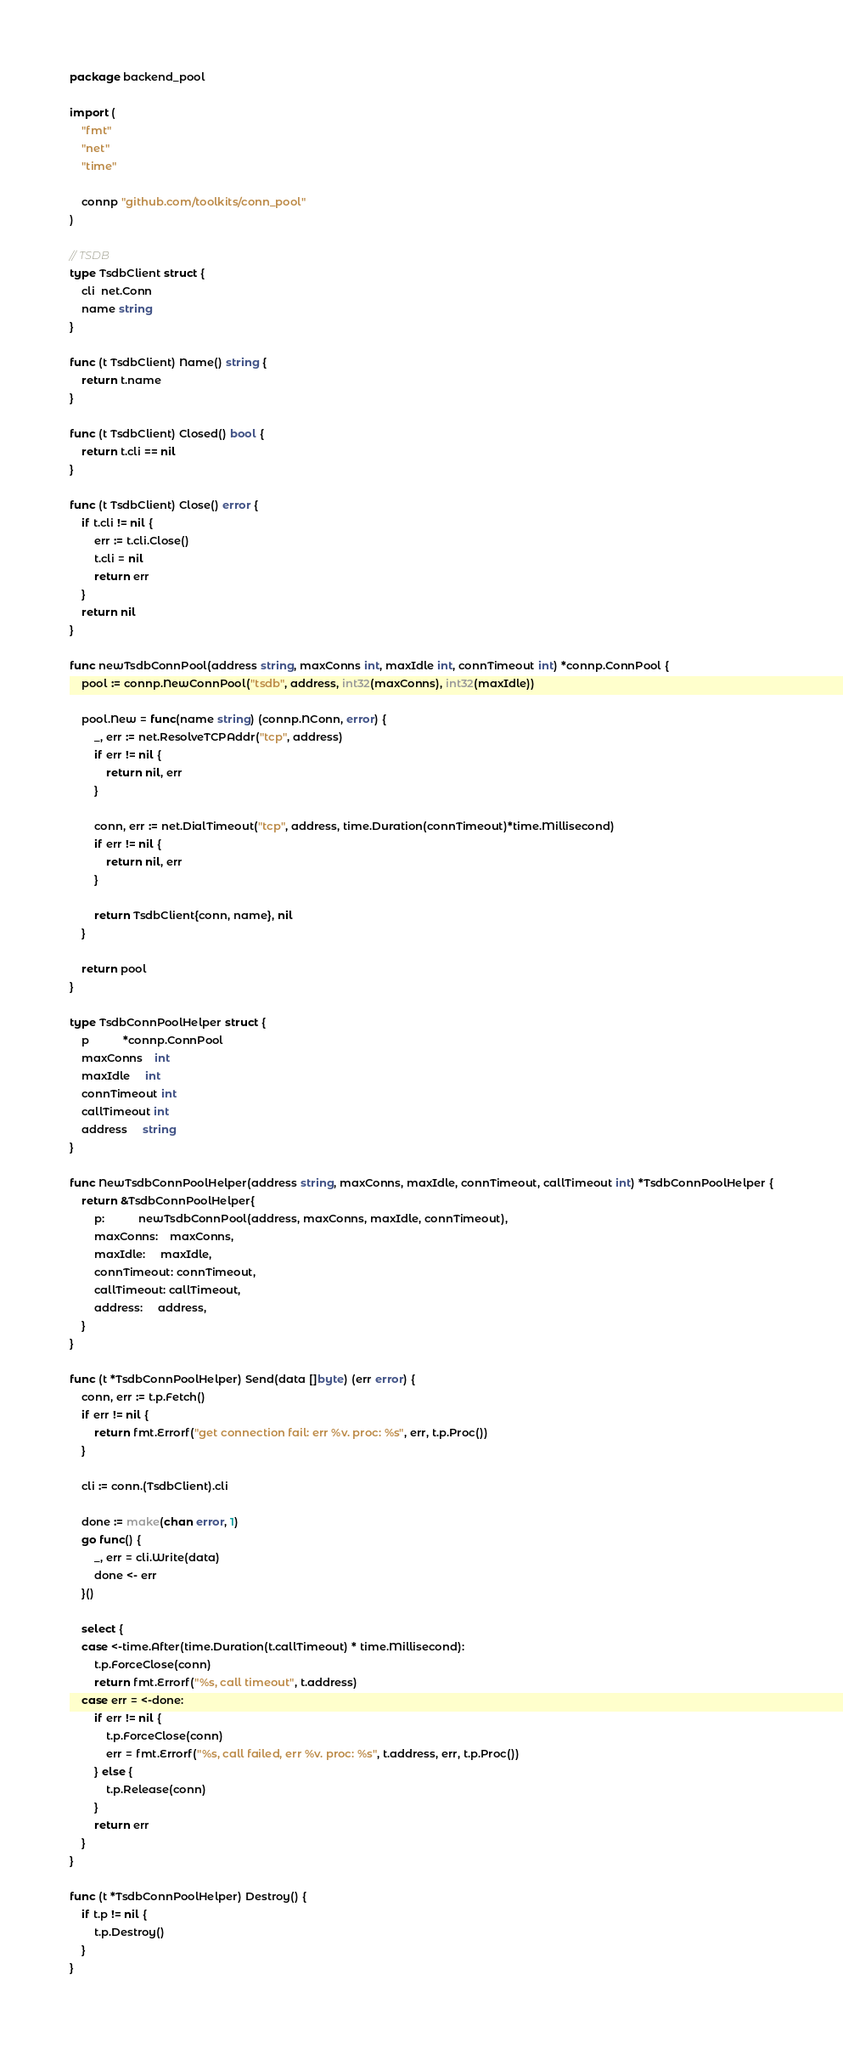<code> <loc_0><loc_0><loc_500><loc_500><_Go_>package backend_pool

import (
	"fmt"
	"net"
	"time"

	connp "github.com/toolkits/conn_pool"
)

// TSDB
type TsdbClient struct {
	cli  net.Conn
	name string
}

func (t TsdbClient) Name() string {
	return t.name
}

func (t TsdbClient) Closed() bool {
	return t.cli == nil
}

func (t TsdbClient) Close() error {
	if t.cli != nil {
		err := t.cli.Close()
		t.cli = nil
		return err
	}
	return nil
}

func newTsdbConnPool(address string, maxConns int, maxIdle int, connTimeout int) *connp.ConnPool {
	pool := connp.NewConnPool("tsdb", address, int32(maxConns), int32(maxIdle))

	pool.New = func(name string) (connp.NConn, error) {
		_, err := net.ResolveTCPAddr("tcp", address)
		if err != nil {
			return nil, err
		}

		conn, err := net.DialTimeout("tcp", address, time.Duration(connTimeout)*time.Millisecond)
		if err != nil {
			return nil, err
		}

		return TsdbClient{conn, name}, nil
	}

	return pool
}

type TsdbConnPoolHelper struct {
	p           *connp.ConnPool
	maxConns    int
	maxIdle     int
	connTimeout int
	callTimeout int
	address     string
}

func NewTsdbConnPoolHelper(address string, maxConns, maxIdle, connTimeout, callTimeout int) *TsdbConnPoolHelper {
	return &TsdbConnPoolHelper{
		p:           newTsdbConnPool(address, maxConns, maxIdle, connTimeout),
		maxConns:    maxConns,
		maxIdle:     maxIdle,
		connTimeout: connTimeout,
		callTimeout: callTimeout,
		address:     address,
	}
}

func (t *TsdbConnPoolHelper) Send(data []byte) (err error) {
	conn, err := t.p.Fetch()
	if err != nil {
		return fmt.Errorf("get connection fail: err %v. proc: %s", err, t.p.Proc())
	}

	cli := conn.(TsdbClient).cli

	done := make(chan error, 1)
	go func() {
		_, err = cli.Write(data)
		done <- err
	}()

	select {
	case <-time.After(time.Duration(t.callTimeout) * time.Millisecond):
		t.p.ForceClose(conn)
		return fmt.Errorf("%s, call timeout", t.address)
	case err = <-done:
		if err != nil {
			t.p.ForceClose(conn)
			err = fmt.Errorf("%s, call failed, err %v. proc: %s", t.address, err, t.p.Proc())
		} else {
			t.p.Release(conn)
		}
		return err
	}
}

func (t *TsdbConnPoolHelper) Destroy() {
	if t.p != nil {
		t.p.Destroy()
	}
}
</code> 